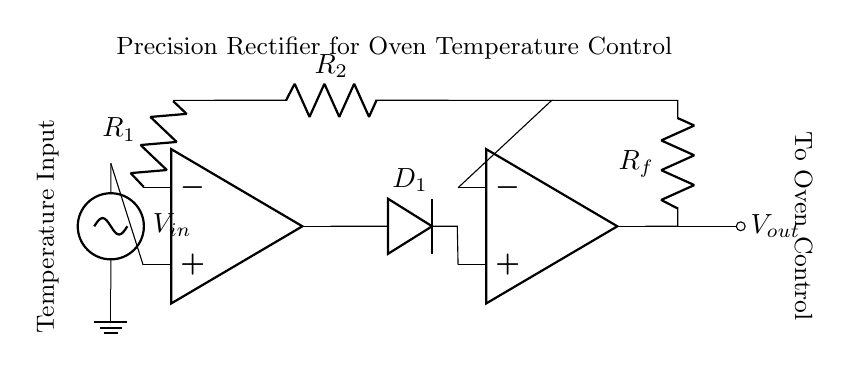What is the type of rectifier in this circuit? This circuit is a precision rectifier, indicated by the presence of operational amplifiers and diodes used in the configuration to accurately control the temperature signal without the common voltage drop associated with standard diodes.
Answer: precision rectifier How many resistors are present in the circuit? The circuit contains three resistors labeled as R1, R2, and Rf. Counting these visible components leads to the total number of resistors being three.
Answer: 3 What is the function of the diode in this circuit? The diode (D1) allows current to flow only in one direction, enabling the rectification of the temperature input signal, which is essential for creating a control signal suitable for the oven.
Answer: rectification Where is the temperature input connected? The temperature input is connected to the positive terminal of the first operational amplifier (opamp1). This indicates it serves as the input signal for the precision rectifier operation.
Answer: opamp1 positive terminal What happens to the output voltage as the input temperature increases? As the input temperature increases, the output voltage (Vout) increases proportionally due to the nature of the precision rectifier and the configuration of the op-amps, effectively controlling the oven temperature.
Answer: increases What does the resistor Rf do in the circuit? Resistor Rf is the feedback resistor that defines the gain of the output voltage, playing a crucial role in determining how much the output reflects changes in the input temperature signal.
Answer: defines gain What is the purpose of connecting the output to the oven control? The output is connected to the oven control to regulate the oven's temperature actively by adjusting the heating element based on the rectified temperature signal, ensuring it maintains the desired baking conditions.
Answer: temperature regulation 